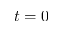<formula> <loc_0><loc_0><loc_500><loc_500>t = 0</formula> 